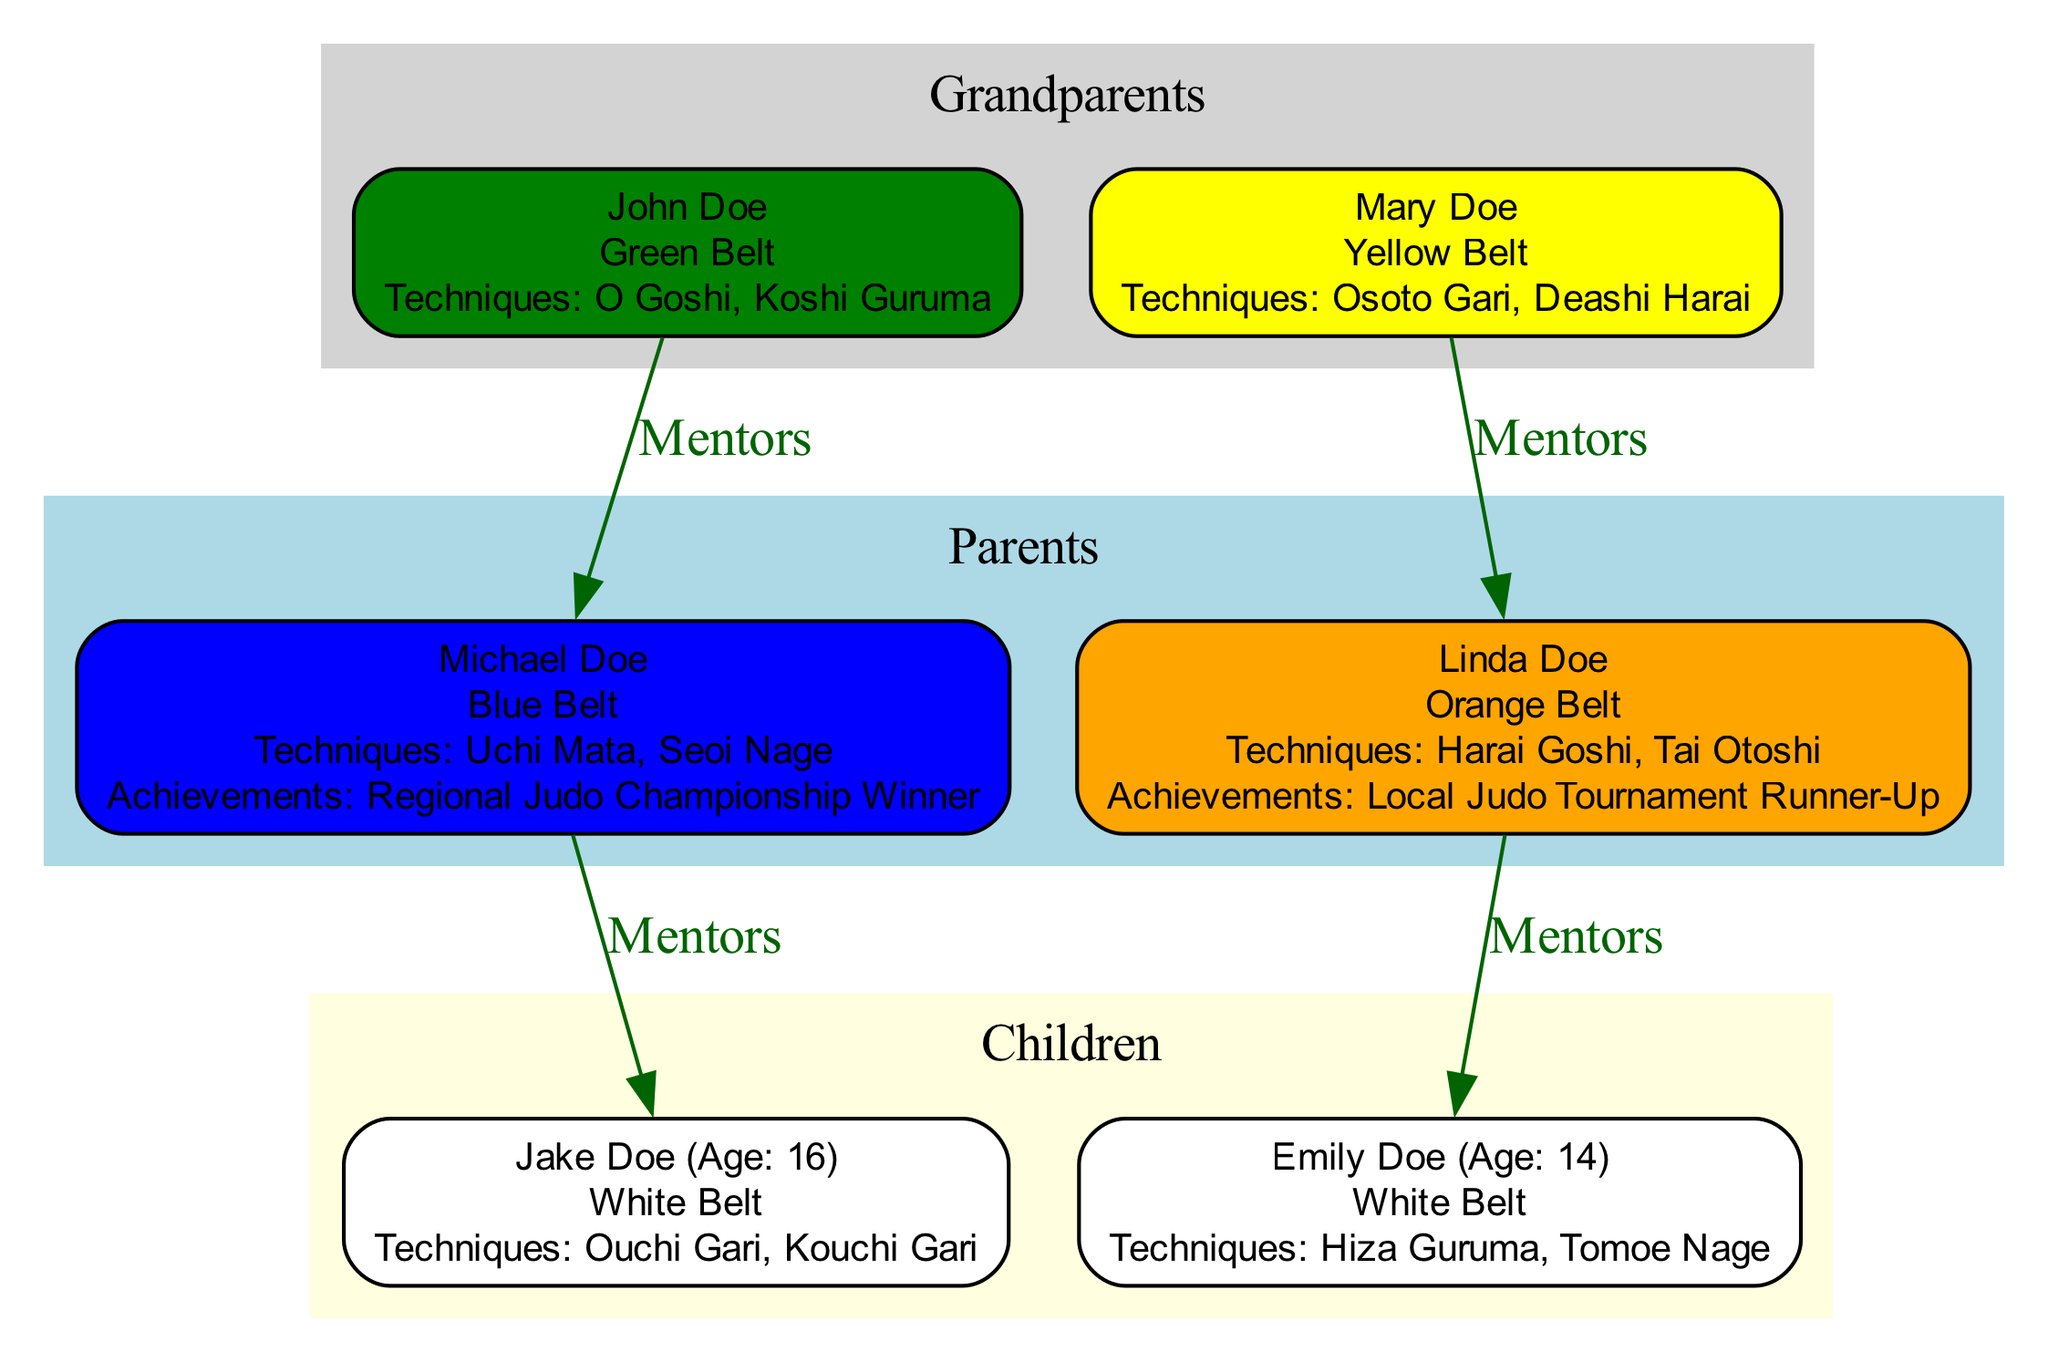What is the Judo Belt Rank of John Doe? The diagram shows that John Doe has a Judo Belt Rank of "Green Belt". This information is located in the Grandparents section of the diagram, under his name.
Answer: Green Belt Who is Emily Doe's mentor? According to the diagram, Emily Doe's mentor is listed as "Linda Doe". This connection is indicated by the mentorship edge directed from Linda to Emily.
Answer: Linda Doe How many special techniques does Michael Doe know? The diagram indicates that Michael Doe has two special techniques: "Uchi Mata" and "Seoi Nage". This information is detailed under his name.
Answer: 2 What is the age of Jake Doe? The diagram specifies that Jake Doe is currently 16 years old, noted in parentheses next to his name in the Children section.
Answer: 16 Which family member is a Regional Judo Championship Winner? The diagram shows that Michael Doe achieved the title of "Regional Judo Championship Winner". This achievement is mentioned next to his name in the Parents section.
Answer: Michael Doe How many children are mentioned in the diagram? The diagram lists two children in the Children section: Jake Doe and Emily Doe. They are both nodes under this section, indicating they are the offspring of the parents.
Answer: 2 What special technique is shared by both grandparents? The special technique "O Goshi" is specifically listed for John Doe in the Grandparents section, and there are no overlap or shared techniques mentioned between the grandparents. Therefore, there is no special technique shared by both grandparents.
Answer: None What color is associated with the Orange Belt? The color associated with the Orange Belt, as indicated by the color scheme in the diagram, is "#FFA500", which is a shade of orange. This color fills the node for Linda Doe who holds this belt rank.
Answer: Orange Which grandparent has a higher Judo Belt Rank? The comparison between the Judo Belt Ranks of the grandparents shows that John Doe is a Green Belt, while Mary Doe is a Yellow Belt. Since Green Belt is ranked higher than Yellow Belt, John Doe holds the higher rank.
Answer: John Doe 